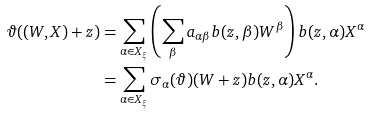Convert formula to latex. <formula><loc_0><loc_0><loc_500><loc_500>\vartheta ( ( W , X ) + z ) & = \sum _ { \alpha \in X _ { \xi } } \left ( \sum _ { \beta } a _ { \alpha \beta } b ( z , \beta ) W ^ { \beta } \right ) b ( z , \alpha ) X ^ { \alpha } \\ & = \sum _ { \alpha \in X _ { \xi } } \sigma _ { \alpha } ( \vartheta ) ( W + z ) b ( z , \alpha ) X ^ { \alpha } .</formula> 